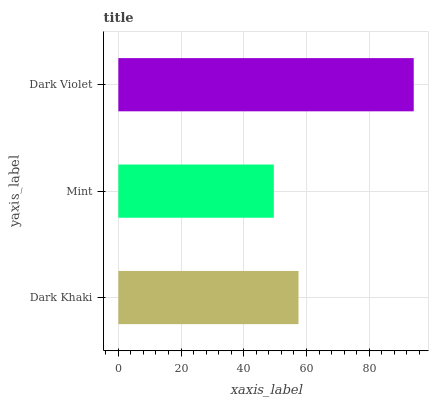Is Mint the minimum?
Answer yes or no. Yes. Is Dark Violet the maximum?
Answer yes or no. Yes. Is Dark Violet the minimum?
Answer yes or no. No. Is Mint the maximum?
Answer yes or no. No. Is Dark Violet greater than Mint?
Answer yes or no. Yes. Is Mint less than Dark Violet?
Answer yes or no. Yes. Is Mint greater than Dark Violet?
Answer yes or no. No. Is Dark Violet less than Mint?
Answer yes or no. No. Is Dark Khaki the high median?
Answer yes or no. Yes. Is Dark Khaki the low median?
Answer yes or no. Yes. Is Mint the high median?
Answer yes or no. No. Is Mint the low median?
Answer yes or no. No. 